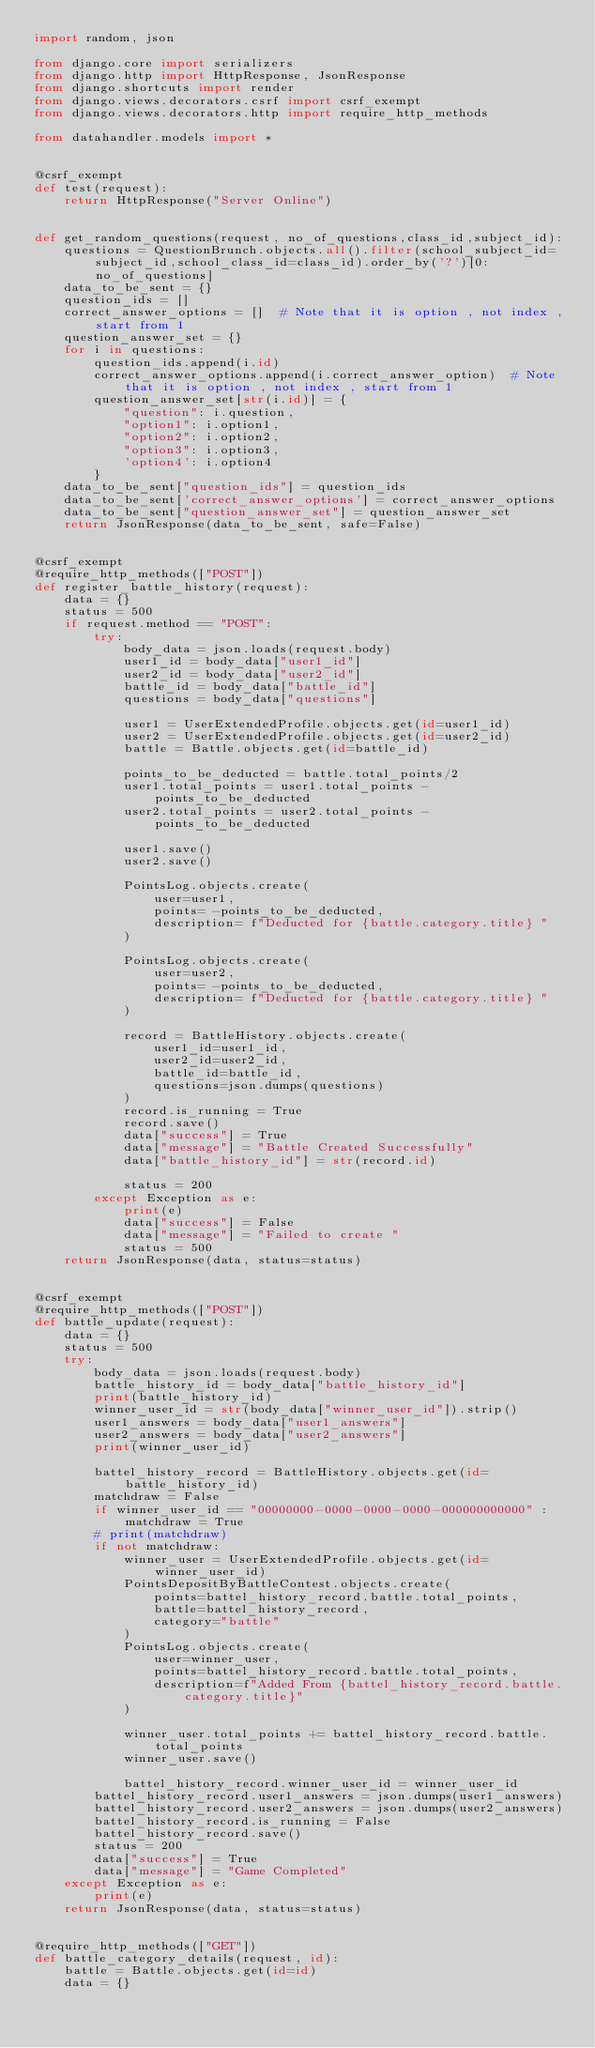Convert code to text. <code><loc_0><loc_0><loc_500><loc_500><_Python_>import random, json

from django.core import serializers
from django.http import HttpResponse, JsonResponse
from django.shortcuts import render
from django.views.decorators.csrf import csrf_exempt
from django.views.decorators.http import require_http_methods

from datahandler.models import *


@csrf_exempt
def test(request):
    return HttpResponse("Server Online")


def get_random_questions(request, no_of_questions,class_id,subject_id):
    questions = QuestionBrunch.objects.all().filter(school_subject_id=subject_id,school_class_id=class_id).order_by('?')[0:no_of_questions]
    data_to_be_sent = {}
    question_ids = []
    correct_answer_options = []  # Note that it is option , not index , start from 1
    question_answer_set = {}
    for i in questions:
        question_ids.append(i.id)
        correct_answer_options.append(i.correct_answer_option)  # Note that it is option , not index , start from 1
        question_answer_set[str(i.id)] = {
            "question": i.question,
            "option1": i.option1,
            "option2": i.option2,
            "option3": i.option3,
            'option4': i.option4
        }
    data_to_be_sent["question_ids"] = question_ids
    data_to_be_sent['correct_answer_options'] = correct_answer_options
    data_to_be_sent["question_answer_set"] = question_answer_set
    return JsonResponse(data_to_be_sent, safe=False)


@csrf_exempt
@require_http_methods(["POST"])
def register_battle_history(request):
    data = {}
    status = 500
    if request.method == "POST":
        try:
            body_data = json.loads(request.body)
            user1_id = body_data["user1_id"]
            user2_id = body_data["user2_id"]
            battle_id = body_data["battle_id"]
            questions = body_data["questions"]

            user1 = UserExtendedProfile.objects.get(id=user1_id)
            user2 = UserExtendedProfile.objects.get(id=user2_id)
            battle = Battle.objects.get(id=battle_id)

            points_to_be_deducted = battle.total_points/2
            user1.total_points = user1.total_points - points_to_be_deducted
            user2.total_points = user2.total_points - points_to_be_deducted

            user1.save()
            user2.save()

            PointsLog.objects.create(
                user=user1,
                points= -points_to_be_deducted,
                description= f"Deducted for {battle.category.title} "
            )

            PointsLog.objects.create(
                user=user2,
                points= -points_to_be_deducted,
                description= f"Deducted for {battle.category.title} "
            )

            record = BattleHistory.objects.create(
                user1_id=user1_id,
                user2_id=user2_id,
                battle_id=battle_id,
                questions=json.dumps(questions)
            )
            record.is_running = True
            record.save()
            data["success"] = True
            data["message"] = "Battle Created Successfully"
            data["battle_history_id"] = str(record.id)

            status = 200
        except Exception as e:
            print(e)
            data["success"] = False
            data["message"] = "Failed to create "
            status = 500
    return JsonResponse(data, status=status)


@csrf_exempt
@require_http_methods(["POST"])
def battle_update(request):
    data = {}
    status = 500
    try:
        body_data = json.loads(request.body)
        battle_history_id = body_data["battle_history_id"]
        print(battle_history_id)
        winner_user_id = str(body_data["winner_user_id"]).strip()
        user1_answers = body_data["user1_answers"]
        user2_answers = body_data["user2_answers"]
        print(winner_user_id)

        battel_history_record = BattleHistory.objects.get(id=battle_history_id)
        matchdraw = False
        if winner_user_id == "00000000-0000-0000-0000-000000000000" : matchdraw = True
        # print(matchdraw)
        if not matchdraw:
            winner_user = UserExtendedProfile.objects.get(id=winner_user_id)
            PointsDepositByBattleContest.objects.create(
                points=battel_history_record.battle.total_points,
                battle=battel_history_record,
                category="battle"
            )
            PointsLog.objects.create(
                user=winner_user,
                points=battel_history_record.battle.total_points,
                description=f"Added From {battel_history_record.battle.category.title}"
            )

            winner_user.total_points += battel_history_record.battle.total_points
            winner_user.save()

            battel_history_record.winner_user_id = winner_user_id
        battel_history_record.user1_answers = json.dumps(user1_answers)
        battel_history_record.user2_answers = json.dumps(user2_answers)
        battel_history_record.is_running = False
        battel_history_record.save()
        status = 200
        data["success"] = True
        data["message"] = "Game Completed"
    except Exception as e:
        print(e)
    return JsonResponse(data, status=status)


@require_http_methods(["GET"])
def battle_category_details(request, id):
    battle = Battle.objects.get(id=id)
    data = {}
</code> 